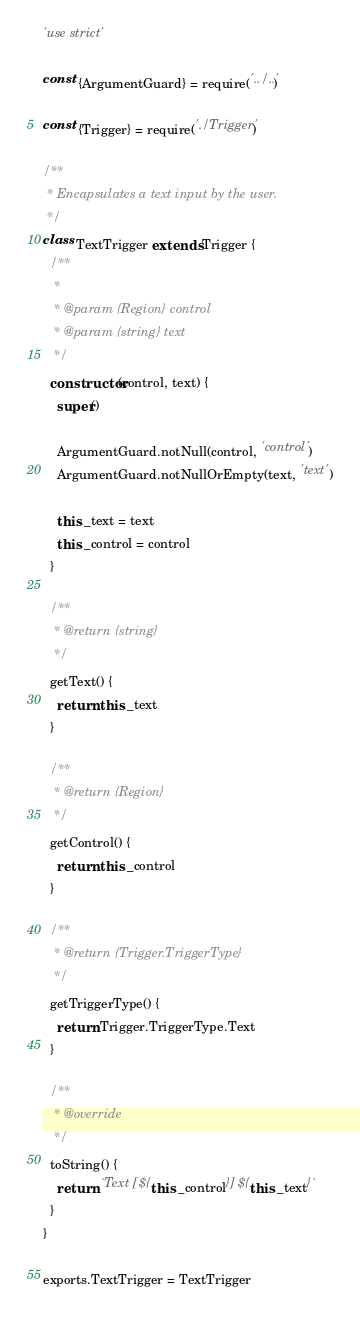Convert code to text. <code><loc_0><loc_0><loc_500><loc_500><_JavaScript_>'use strict'

const {ArgumentGuard} = require('../..')

const {Trigger} = require('./Trigger')

/**
 * Encapsulates a text input by the user.
 */
class TextTrigger extends Trigger {
  /**
   *
   * @param {Region} control
   * @param {string} text
   */
  constructor(control, text) {
    super()

    ArgumentGuard.notNull(control, 'control')
    ArgumentGuard.notNullOrEmpty(text, 'text')

    this._text = text
    this._control = control
  }

  /**
   * @return {string}
   */
  getText() {
    return this._text
  }

  /**
   * @return {Region}
   */
  getControl() {
    return this._control
  }

  /**
   * @return {Trigger.TriggerType}
   */
  getTriggerType() {
    return Trigger.TriggerType.Text
  }

  /**
   * @override
   */
  toString() {
    return `Text [${this._control}] ${this._text}`
  }
}

exports.TextTrigger = TextTrigger
</code> 